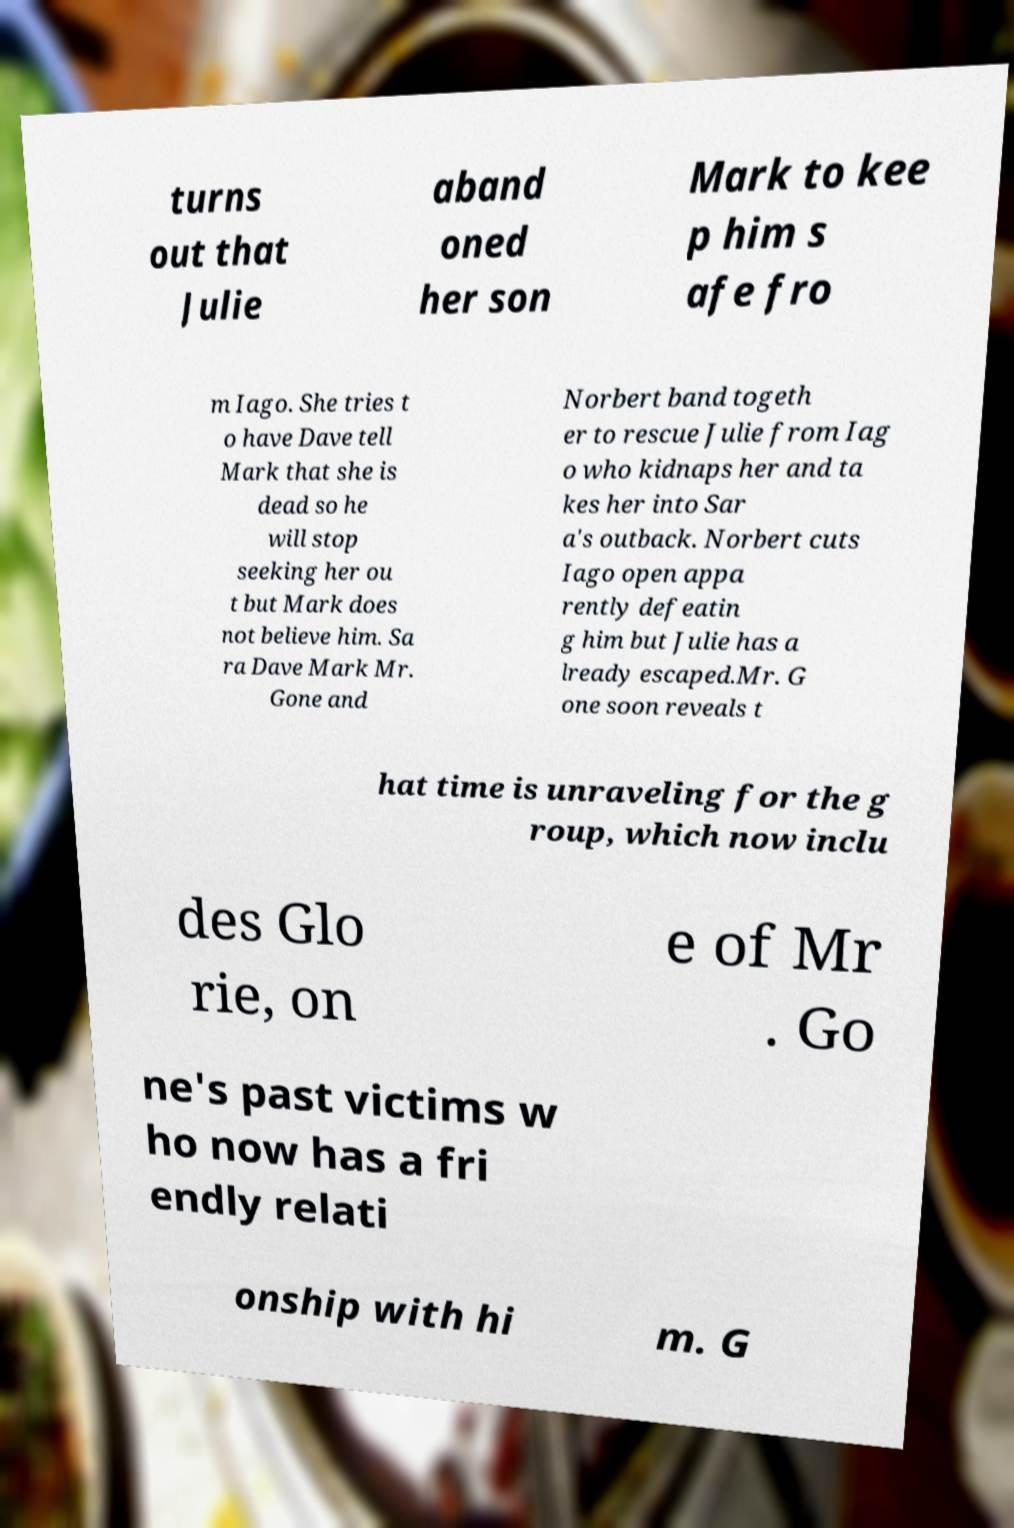Please identify and transcribe the text found in this image. turns out that Julie aband oned her son Mark to kee p him s afe fro m Iago. She tries t o have Dave tell Mark that she is dead so he will stop seeking her ou t but Mark does not believe him. Sa ra Dave Mark Mr. Gone and Norbert band togeth er to rescue Julie from Iag o who kidnaps her and ta kes her into Sar a's outback. Norbert cuts Iago open appa rently defeatin g him but Julie has a lready escaped.Mr. G one soon reveals t hat time is unraveling for the g roup, which now inclu des Glo rie, on e of Mr . Go ne's past victims w ho now has a fri endly relati onship with hi m. G 